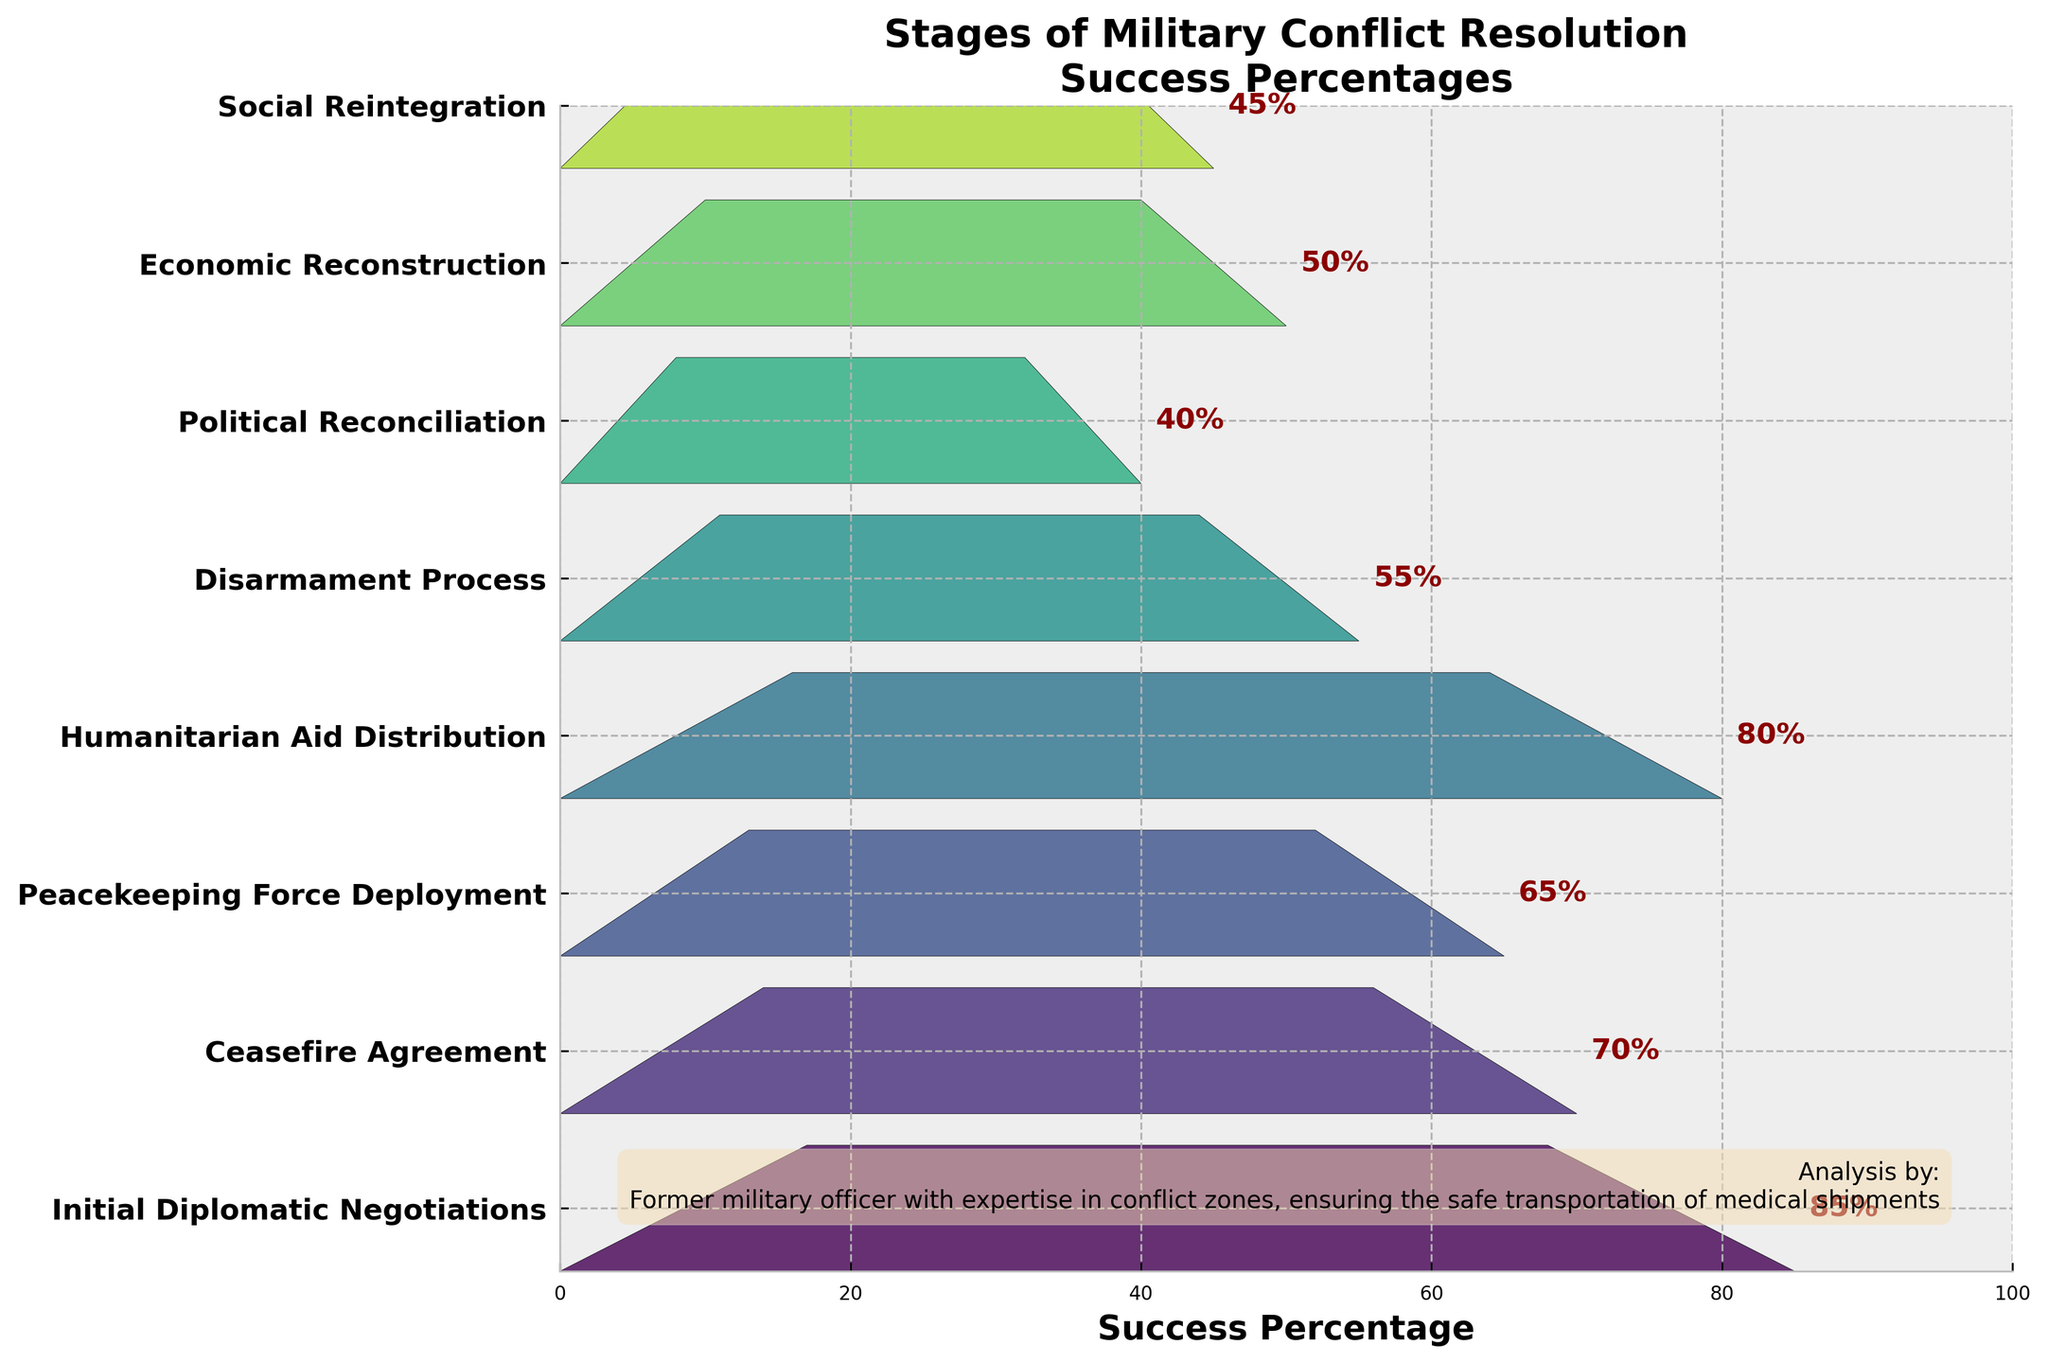What is the stage with the highest success percentage? The "Initial Diplomatic Negotiations" stage has the highest success percentage, which is shown as 85% on the chart.
Answer: Initial Diplomatic Negotiations Which stage follows the "Ceasefire Agreement" stage in the process? The stage that follows "Ceasefire Agreement" is "Peacekeeping Force Deployment," as indicated by the order of stages on the y-axis.
Answer: Peacekeeping Force Deployment What is the success percentage of the "Disarmament Process" stage? The "Disarmament Process" stage has a success percentage of 55%, which is labeled on the chart.
Answer: 55% How many stages have a success percentage lower than 50%? The stages with success percentages lower than 50% are "Political Reconciliation" (40%) and "Social Reintegration" (45%). We count 2 such stages in total.
Answer: 2 Which stage has the lowest success percentage, and what is it? "Political Reconciliation" has the lowest success percentage, which is 40% as per the funnel chart.
Answer: Political Reconciliation, 40% Compare the success percentages of "Economic Reconstruction" and "Humanitarian Aid Distribution." Which one is higher? The "Humanitarian Aid Distribution" stage has a higher success percentage (80%) compared to "Economic Reconstruction" (50%).
Answer: Humanitarian Aid Distribution What is the combined success percentage of "Ceasefire Agreement" and "Disarmament Process"? The combined success percentage is the sum of "Ceasefire Agreement" (70%) and "Disarmament Process" (55%), which totals to 70 + 55 = 125%.
Answer: 125% Which stage comes between "Ceasefire Agreement" and "Humanitarian Aid Distribution"? The stage that comes between "Ceasefire Agreement" and "Humanitarian Aid Distribution" is "Peacekeeping Force Deployment," based on the flow indicated in the funnel chart.
Answer: Peacekeeping Force Deployment If you average the success percentages of the "Initial Diplomatic Negotiations," "Peacekeeping Force Deployment," and "Humanitarian Aid Distribution," what do you get? The success percentages are: Initial Diplomatic Negotiations (85%), Peacekeeping Force Deployment (65%), and Humanitarian Aid Distribution (80%). The average is (85 + 65 + 80) / 3 = 76.67%.
Answer: 76.67% 